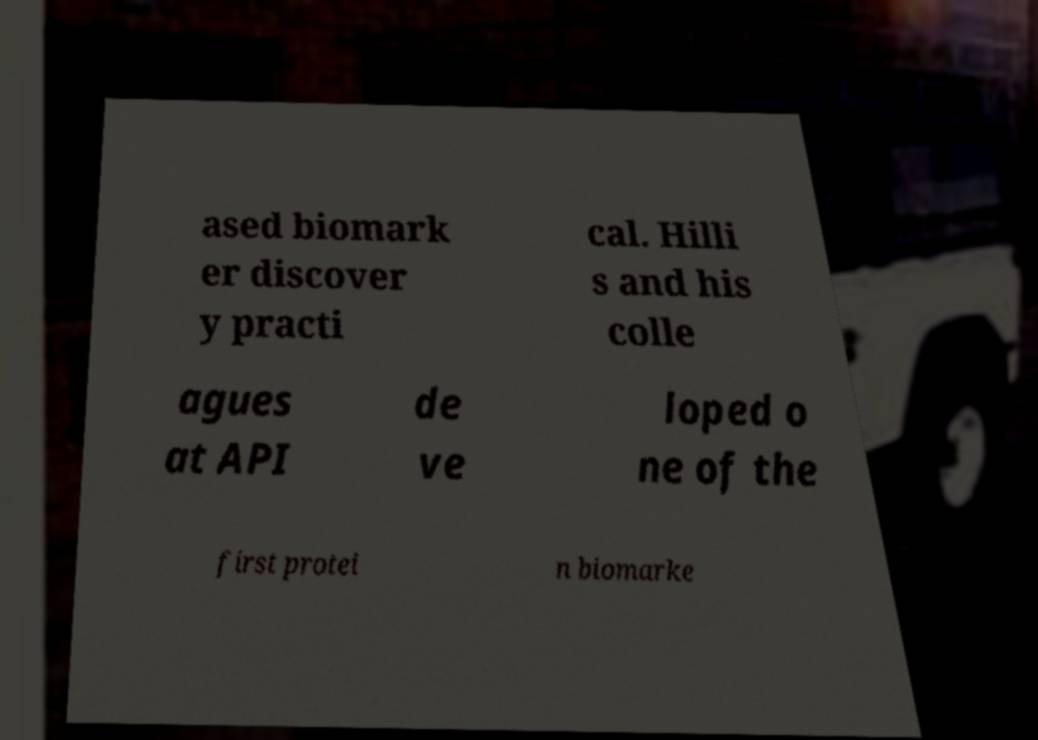For documentation purposes, I need the text within this image transcribed. Could you provide that? ased biomark er discover y practi cal. Hilli s and his colle agues at API de ve loped o ne of the first protei n biomarke 